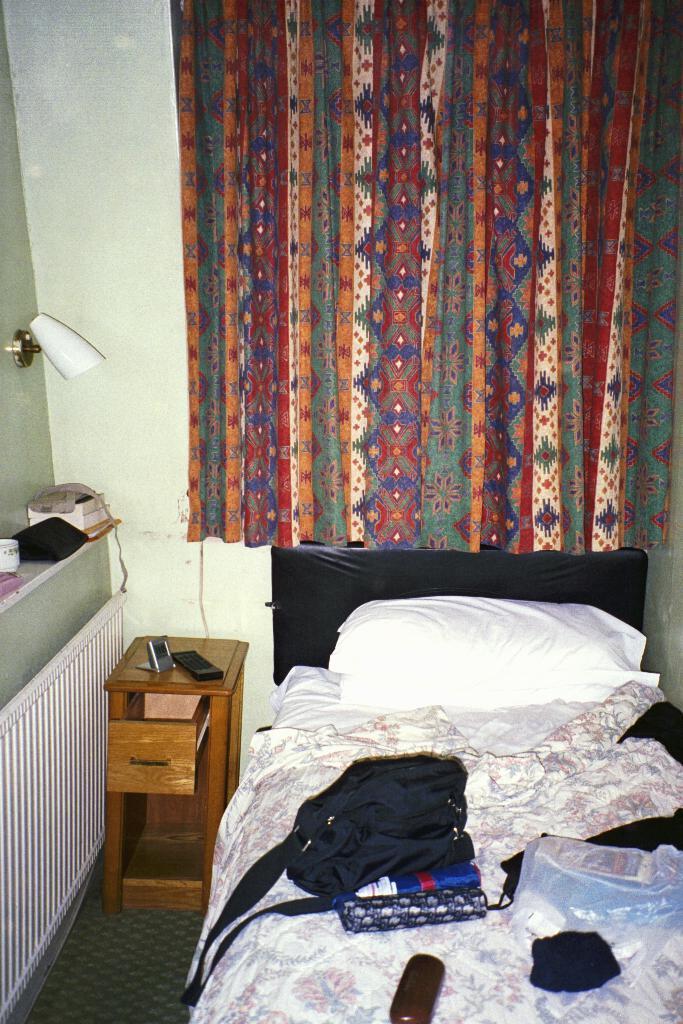Can you describe this image briefly? In this picture we can see pillow, bag, box, cover, clothes and objects on the bed, beside the bed we can see objects on the table. On the left side of the image we can see books and objects on the platform and light. We can see curtain and wall. 